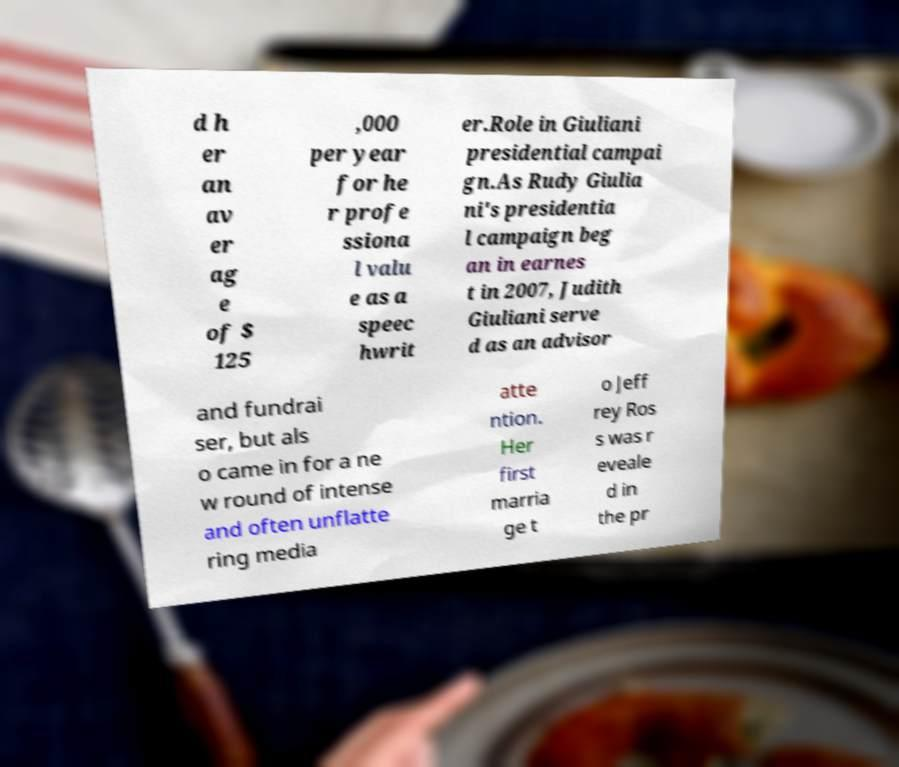Can you read and provide the text displayed in the image?This photo seems to have some interesting text. Can you extract and type it out for me? d h er an av er ag e of $ 125 ,000 per year for he r profe ssiona l valu e as a speec hwrit er.Role in Giuliani presidential campai gn.As Rudy Giulia ni's presidentia l campaign beg an in earnes t in 2007, Judith Giuliani serve d as an advisor and fundrai ser, but als o came in for a ne w round of intense and often unflatte ring media atte ntion. Her first marria ge t o Jeff rey Ros s was r eveale d in the pr 